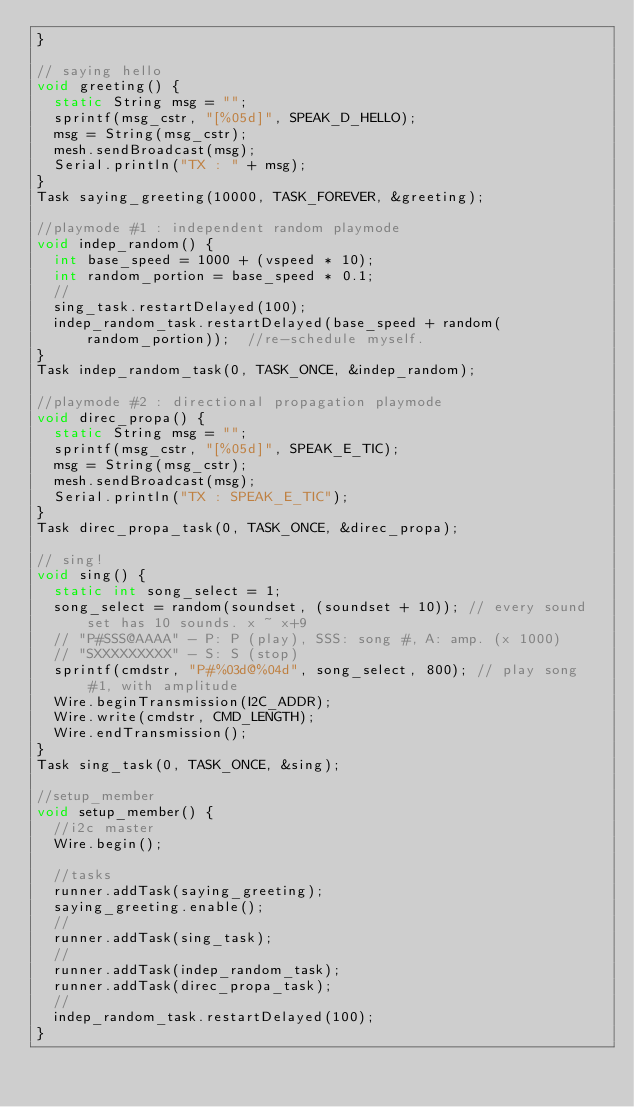Convert code to text. <code><loc_0><loc_0><loc_500><loc_500><_C++_>}

// saying hello
void greeting() {
  static String msg = "";
  sprintf(msg_cstr, "[%05d]", SPEAK_D_HELLO);
  msg = String(msg_cstr);
  mesh.sendBroadcast(msg);
  Serial.println("TX : " + msg);
}
Task saying_greeting(10000, TASK_FOREVER, &greeting);

//playmode #1 : independent random playmode
void indep_random() {
  int base_speed = 1000 + (vspeed * 10);
  int random_portion = base_speed * 0.1;
  //
  sing_task.restartDelayed(100);
  indep_random_task.restartDelayed(base_speed + random(random_portion));  //re-schedule myself.
}
Task indep_random_task(0, TASK_ONCE, &indep_random);

//playmode #2 : directional propagation playmode
void direc_propa() {
  static String msg = "";
  sprintf(msg_cstr, "[%05d]", SPEAK_E_TIC);
  msg = String(msg_cstr);
  mesh.sendBroadcast(msg);
  Serial.println("TX : SPEAK_E_TIC");
}
Task direc_propa_task(0, TASK_ONCE, &direc_propa);

// sing!
void sing() {
  static int song_select = 1;
  song_select = random(soundset, (soundset + 10)); // every sound set has 10 sounds. x ~ x+9
  // "P#SSS@AAAA" - P: P (play), SSS: song #, A: amp. (x 1000)
  // "SXXXXXXXXX" - S: S (stop)
  sprintf(cmdstr, "P#%03d@%04d", song_select, 800); // play song #1, with amplitude
  Wire.beginTransmission(I2C_ADDR);
  Wire.write(cmdstr, CMD_LENGTH);
  Wire.endTransmission();
}
Task sing_task(0, TASK_ONCE, &sing);

//setup_member
void setup_member() {
  //i2c master
  Wire.begin();

  //tasks
  runner.addTask(saying_greeting);
  saying_greeting.enable();
  //
  runner.addTask(sing_task);
  //
  runner.addTask(indep_random_task);
  runner.addTask(direc_propa_task);
  //
  indep_random_task.restartDelayed(100);
}
</code> 